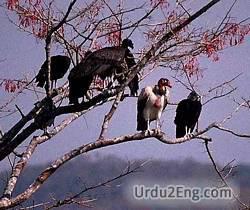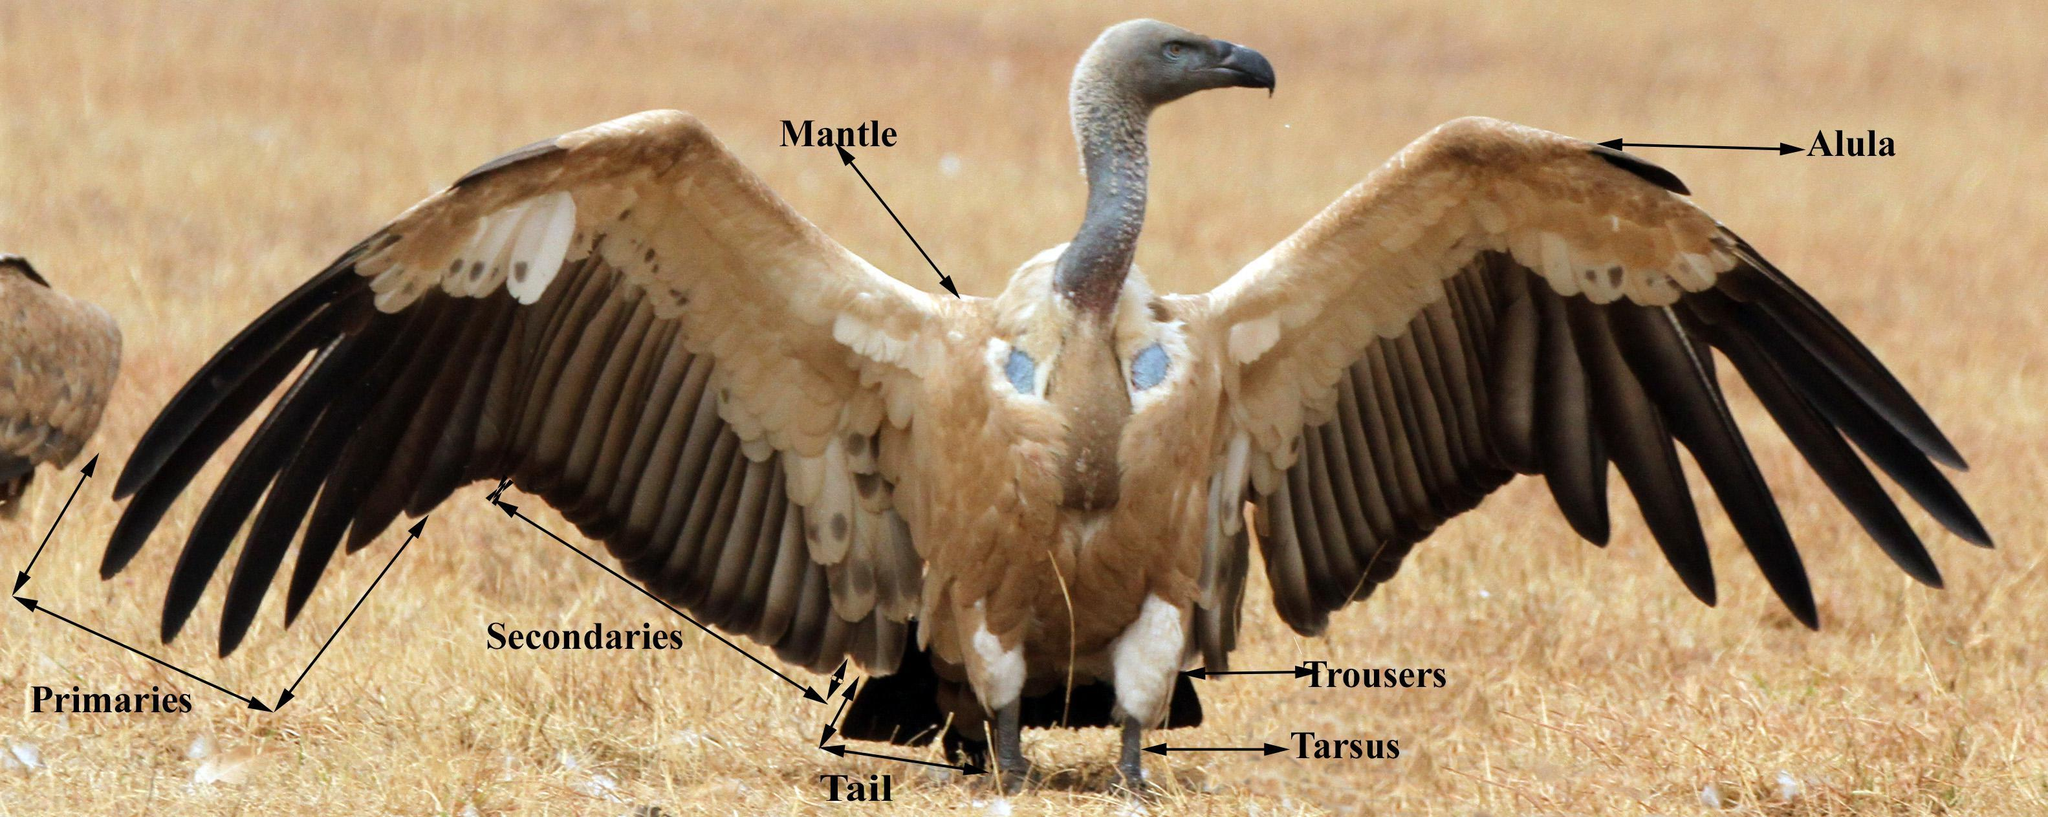The first image is the image on the left, the second image is the image on the right. Examine the images to the left and right. Is the description "There is exactly one bird with its wings folded in the image on the right" accurate? Answer yes or no. No. The first image is the image on the left, the second image is the image on the right. Considering the images on both sides, is "Some of the birds are eating something that is on the ground." valid? Answer yes or no. No. 